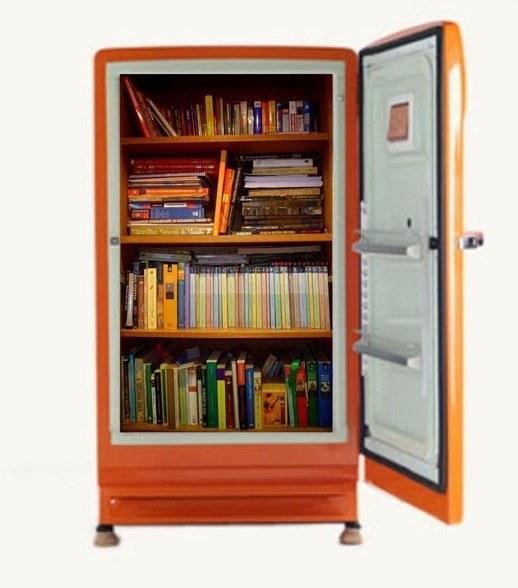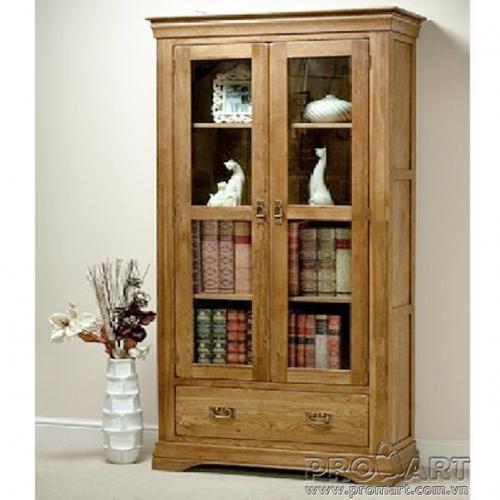The first image is the image on the left, the second image is the image on the right. For the images displayed, is the sentence "At least one image features a bookcase with reddish-brown panels at the bottom and eight vertical shelves." factually correct? Answer yes or no. No. The first image is the image on the left, the second image is the image on the right. Given the left and right images, does the statement "An object is next to one of the bookcases." hold true? Answer yes or no. Yes. 